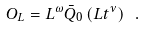Convert formula to latex. <formula><loc_0><loc_0><loc_500><loc_500>O _ { L } = L ^ { \omega } \bar { Q } _ { 0 } \left ( L t ^ { \nu } \right ) \ .</formula> 